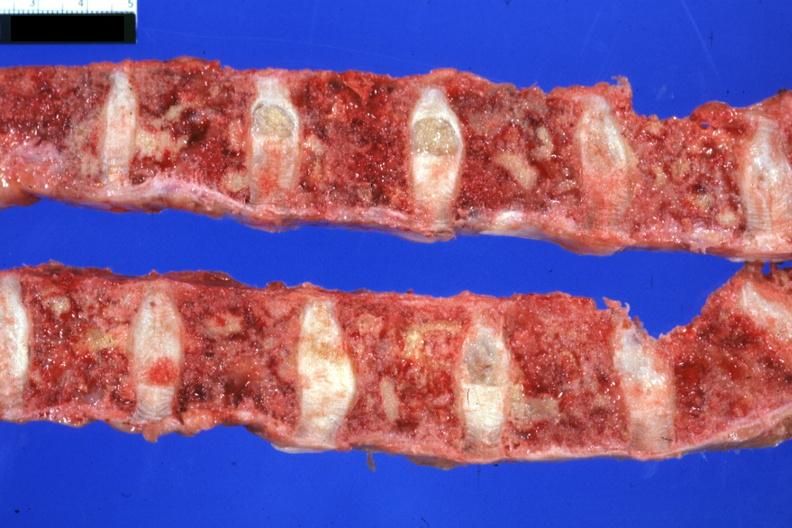what sigmoid colon papillary adenocarcinoma 6mo post colon resection with multiple complications?
Answer the question using a single word or phrase. Excellent lesions 